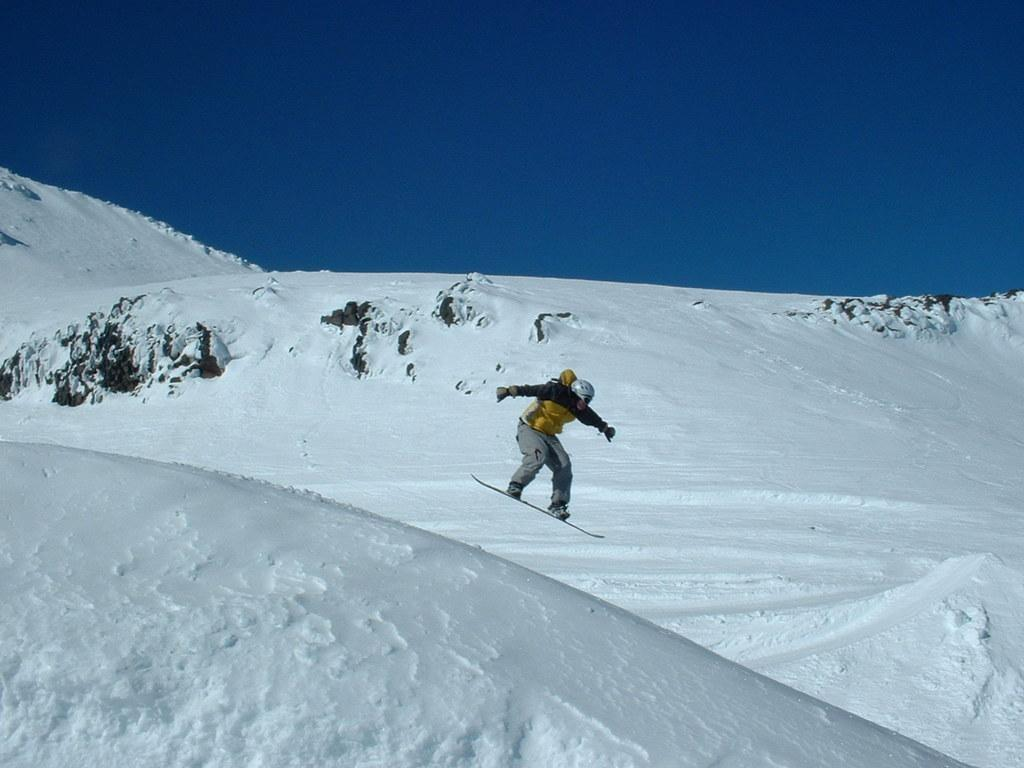What is the person in the image doing? The person is using a snowboard in the image. What type of terrain is visible in the image? The land is covered with snow in the image. What is the color of the sky in the image? The sky is blue in the image. How is the person positioned in relation to the ground? The person is in the air while using the snowboard in the image. What type of paint is being used by the dogs in the image? There are no dogs present in the image, and therefore no paint or painting activity can be observed. 